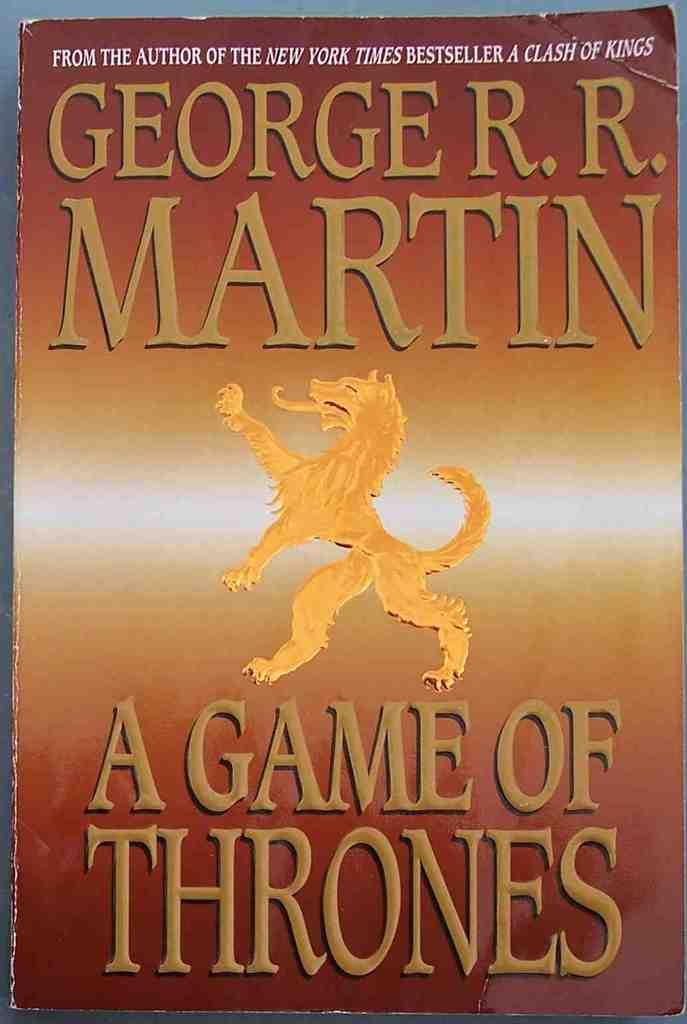<image>
Share a concise interpretation of the image provided. The cover of a Game of Thrones book shows a gold lion 